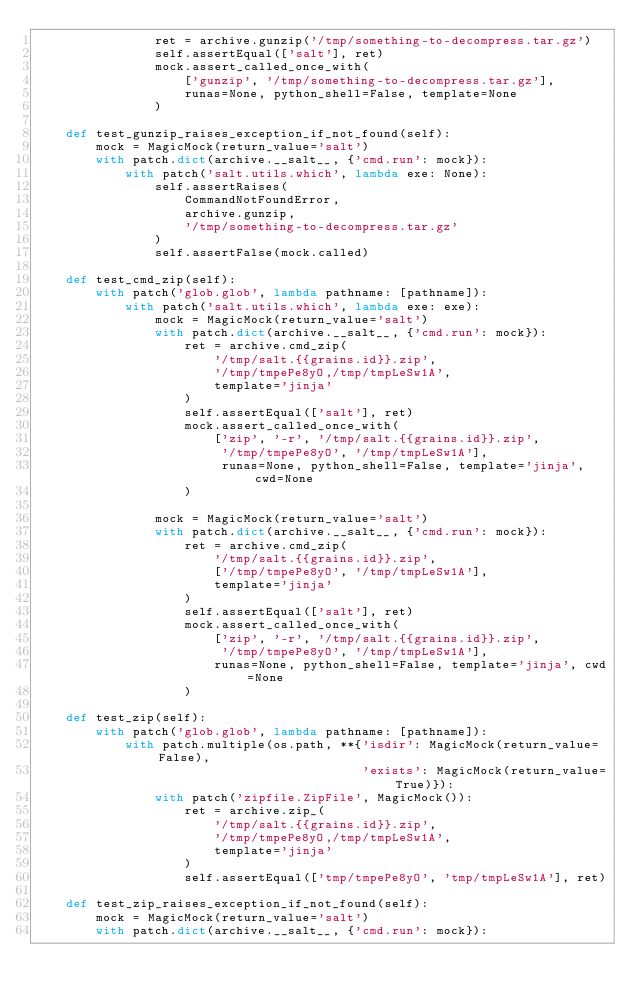Convert code to text. <code><loc_0><loc_0><loc_500><loc_500><_Python_>                ret = archive.gunzip('/tmp/something-to-decompress.tar.gz')
                self.assertEqual(['salt'], ret)
                mock.assert_called_once_with(
                    ['gunzip', '/tmp/something-to-decompress.tar.gz'],
                    runas=None, python_shell=False, template=None
                )

    def test_gunzip_raises_exception_if_not_found(self):
        mock = MagicMock(return_value='salt')
        with patch.dict(archive.__salt__, {'cmd.run': mock}):
            with patch('salt.utils.which', lambda exe: None):
                self.assertRaises(
                    CommandNotFoundError,
                    archive.gunzip,
                    '/tmp/something-to-decompress.tar.gz'
                )
                self.assertFalse(mock.called)

    def test_cmd_zip(self):
        with patch('glob.glob', lambda pathname: [pathname]):
            with patch('salt.utils.which', lambda exe: exe):
                mock = MagicMock(return_value='salt')
                with patch.dict(archive.__salt__, {'cmd.run': mock}):
                    ret = archive.cmd_zip(
                        '/tmp/salt.{{grains.id}}.zip',
                        '/tmp/tmpePe8yO,/tmp/tmpLeSw1A',
                        template='jinja'
                    )
                    self.assertEqual(['salt'], ret)
                    mock.assert_called_once_with(
                        ['zip', '-r', '/tmp/salt.{{grains.id}}.zip',
                         '/tmp/tmpePe8yO', '/tmp/tmpLeSw1A'],
                         runas=None, python_shell=False, template='jinja', cwd=None
                    )

                mock = MagicMock(return_value='salt')
                with patch.dict(archive.__salt__, {'cmd.run': mock}):
                    ret = archive.cmd_zip(
                        '/tmp/salt.{{grains.id}}.zip',
                        ['/tmp/tmpePe8yO', '/tmp/tmpLeSw1A'],
                        template='jinja'
                    )
                    self.assertEqual(['salt'], ret)
                    mock.assert_called_once_with(
                        ['zip', '-r', '/tmp/salt.{{grains.id}}.zip',
                         '/tmp/tmpePe8yO', '/tmp/tmpLeSw1A'],
                        runas=None, python_shell=False, template='jinja', cwd=None
                    )

    def test_zip(self):
        with patch('glob.glob', lambda pathname: [pathname]):
            with patch.multiple(os.path, **{'isdir': MagicMock(return_value=False),
                                            'exists': MagicMock(return_value=True)}):
                with patch('zipfile.ZipFile', MagicMock()):
                    ret = archive.zip_(
                        '/tmp/salt.{{grains.id}}.zip',
                        '/tmp/tmpePe8yO,/tmp/tmpLeSw1A',
                        template='jinja'
                    )
                    self.assertEqual(['tmp/tmpePe8yO', 'tmp/tmpLeSw1A'], ret)

    def test_zip_raises_exception_if_not_found(self):
        mock = MagicMock(return_value='salt')
        with patch.dict(archive.__salt__, {'cmd.run': mock}):</code> 